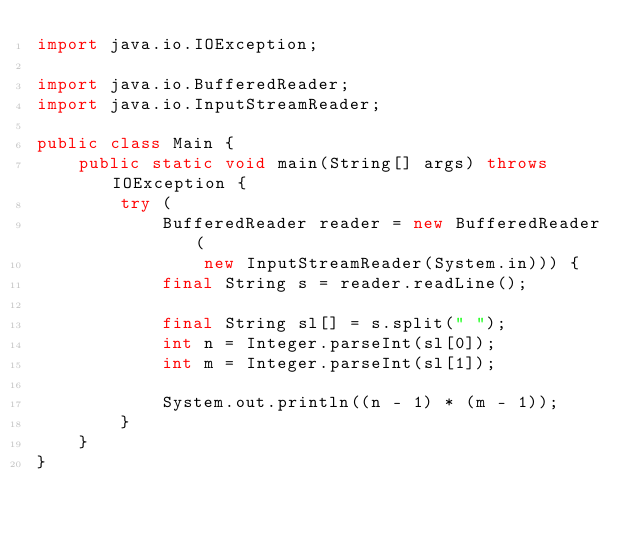Convert code to text. <code><loc_0><loc_0><loc_500><loc_500><_Java_>import java.io.IOException;

import java.io.BufferedReader;
import java.io.InputStreamReader;

public class Main {
    public static void main(String[] args) throws IOException {
        try (
            BufferedReader reader = new BufferedReader(
                new InputStreamReader(System.in))) {
            final String s = reader.readLine();

            final String sl[] = s.split(" ");
            int n = Integer.parseInt(sl[0]);
            int m = Integer.parseInt(sl[1]);

            System.out.println((n - 1) * (m - 1));
        }
    }
}
</code> 